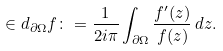<formula> <loc_0><loc_0><loc_500><loc_500>\in d _ { \partial \Omega } f \colon = \frac { 1 } { 2 i \pi } \int _ { \partial \Omega } \frac { f ^ { \prime } ( z ) } { f ( z ) } \, d z .</formula> 